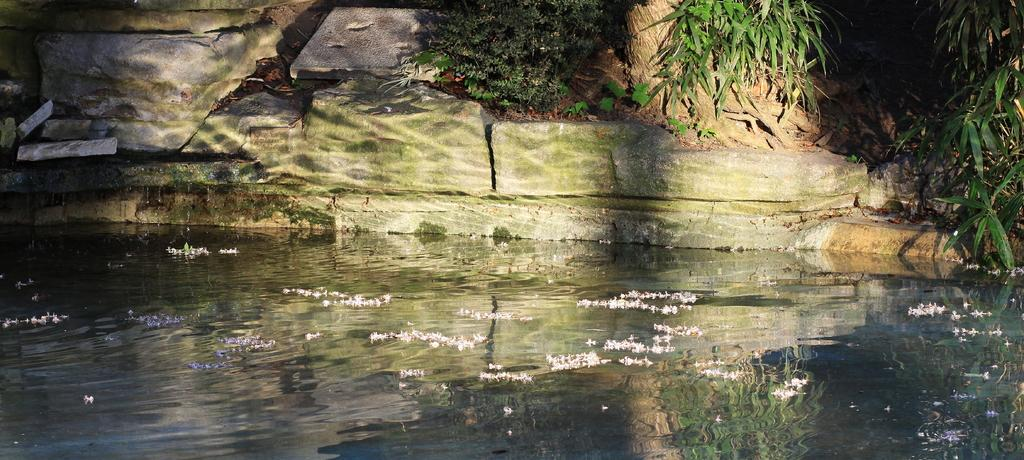What is floating on the water in the image? There are flowers floating on the water in the image. What other objects can be seen in the image? There are rocks and plants visible in the image. Can you describe the tree trunk in the image? There is a tree trunk with roots in the image. What type of card is being used to scare away the jeans in the image? There is no card, fear, or jeans present in the image. 